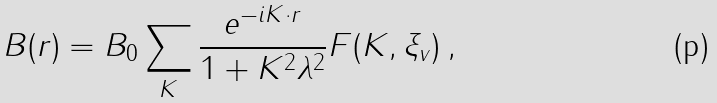Convert formula to latex. <formula><loc_0><loc_0><loc_500><loc_500>B ( { r } ) = B _ { 0 } \sum _ { K } \frac { e ^ { - i { K } \cdot { r } } } { 1 + K ^ { 2 } \lambda ^ { 2 } } F ( K , \xi _ { v } ) \, ,</formula> 